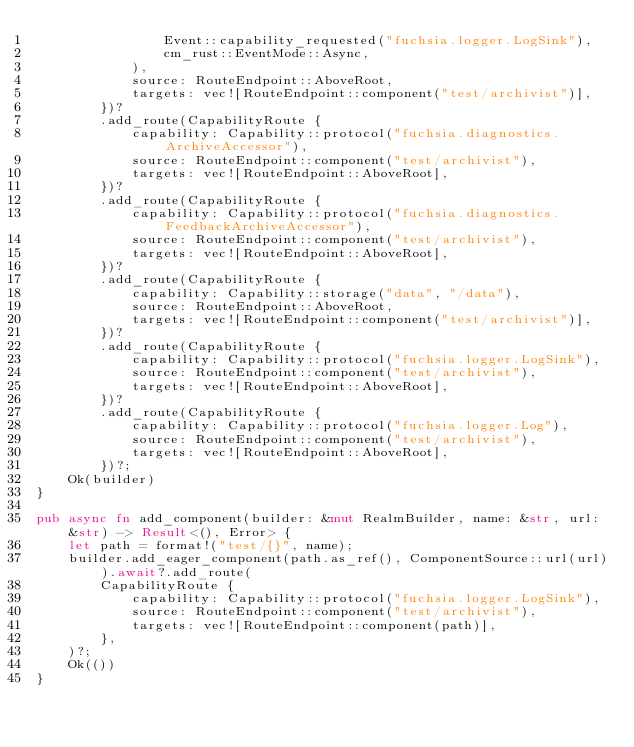Convert code to text. <code><loc_0><loc_0><loc_500><loc_500><_Rust_>                Event::capability_requested("fuchsia.logger.LogSink"),
                cm_rust::EventMode::Async,
            ),
            source: RouteEndpoint::AboveRoot,
            targets: vec![RouteEndpoint::component("test/archivist")],
        })?
        .add_route(CapabilityRoute {
            capability: Capability::protocol("fuchsia.diagnostics.ArchiveAccessor"),
            source: RouteEndpoint::component("test/archivist"),
            targets: vec![RouteEndpoint::AboveRoot],
        })?
        .add_route(CapabilityRoute {
            capability: Capability::protocol("fuchsia.diagnostics.FeedbackArchiveAccessor"),
            source: RouteEndpoint::component("test/archivist"),
            targets: vec![RouteEndpoint::AboveRoot],
        })?
        .add_route(CapabilityRoute {
            capability: Capability::storage("data", "/data"),
            source: RouteEndpoint::AboveRoot,
            targets: vec![RouteEndpoint::component("test/archivist")],
        })?
        .add_route(CapabilityRoute {
            capability: Capability::protocol("fuchsia.logger.LogSink"),
            source: RouteEndpoint::component("test/archivist"),
            targets: vec![RouteEndpoint::AboveRoot],
        })?
        .add_route(CapabilityRoute {
            capability: Capability::protocol("fuchsia.logger.Log"),
            source: RouteEndpoint::component("test/archivist"),
            targets: vec![RouteEndpoint::AboveRoot],
        })?;
    Ok(builder)
}

pub async fn add_component(builder: &mut RealmBuilder, name: &str, url: &str) -> Result<(), Error> {
    let path = format!("test/{}", name);
    builder.add_eager_component(path.as_ref(), ComponentSource::url(url)).await?.add_route(
        CapabilityRoute {
            capability: Capability::protocol("fuchsia.logger.LogSink"),
            source: RouteEndpoint::component("test/archivist"),
            targets: vec![RouteEndpoint::component(path)],
        },
    )?;
    Ok(())
}
</code> 